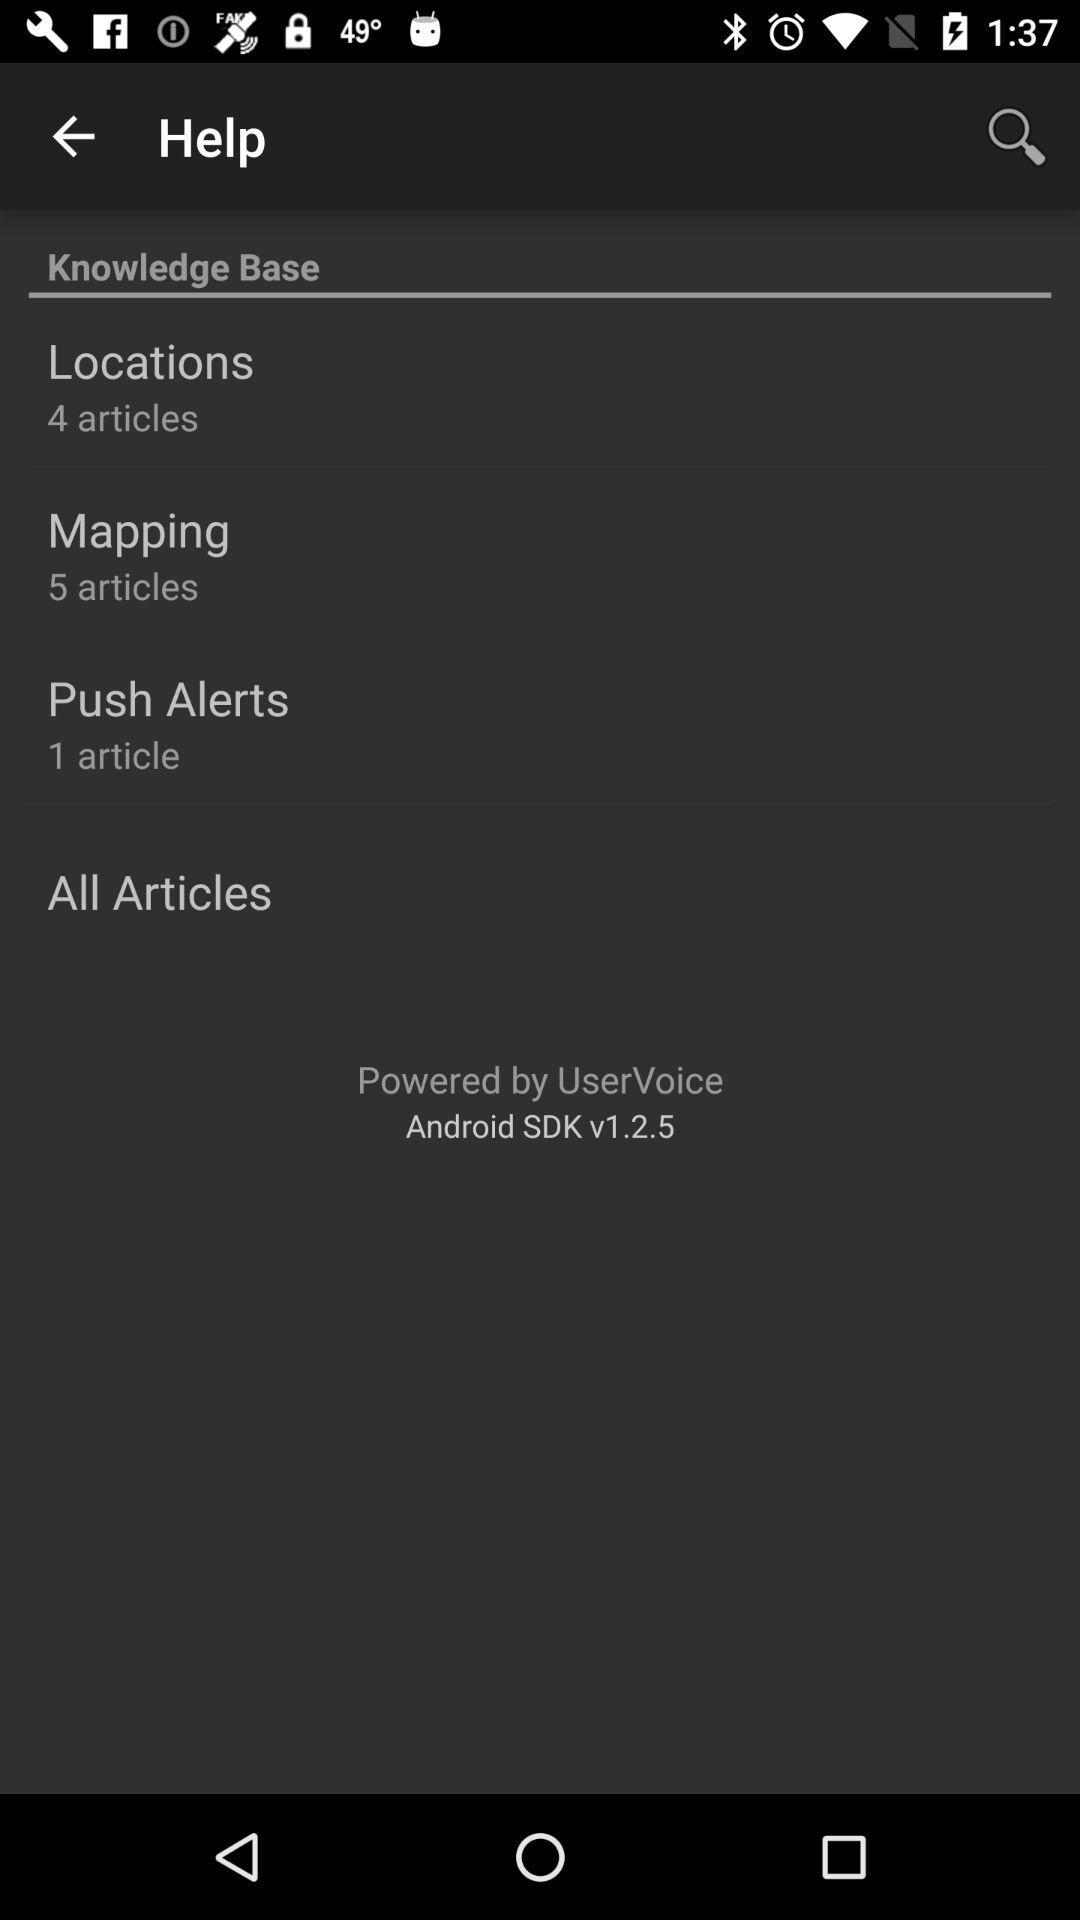How many articles are there in total?
Answer the question using a single word or phrase. 10 